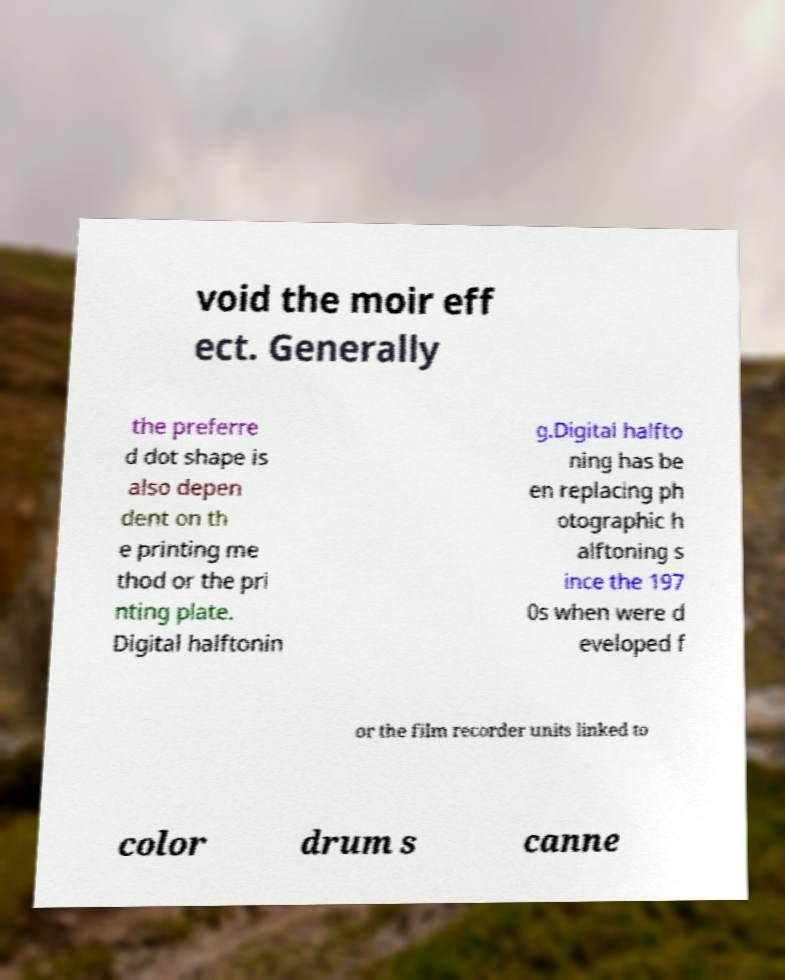What messages or text are displayed in this image? I need them in a readable, typed format. void the moir eff ect. Generally the preferre d dot shape is also depen dent on th e printing me thod or the pri nting plate. Digital halftonin g.Digital halfto ning has be en replacing ph otographic h alftoning s ince the 197 0s when were d eveloped f or the film recorder units linked to color drum s canne 